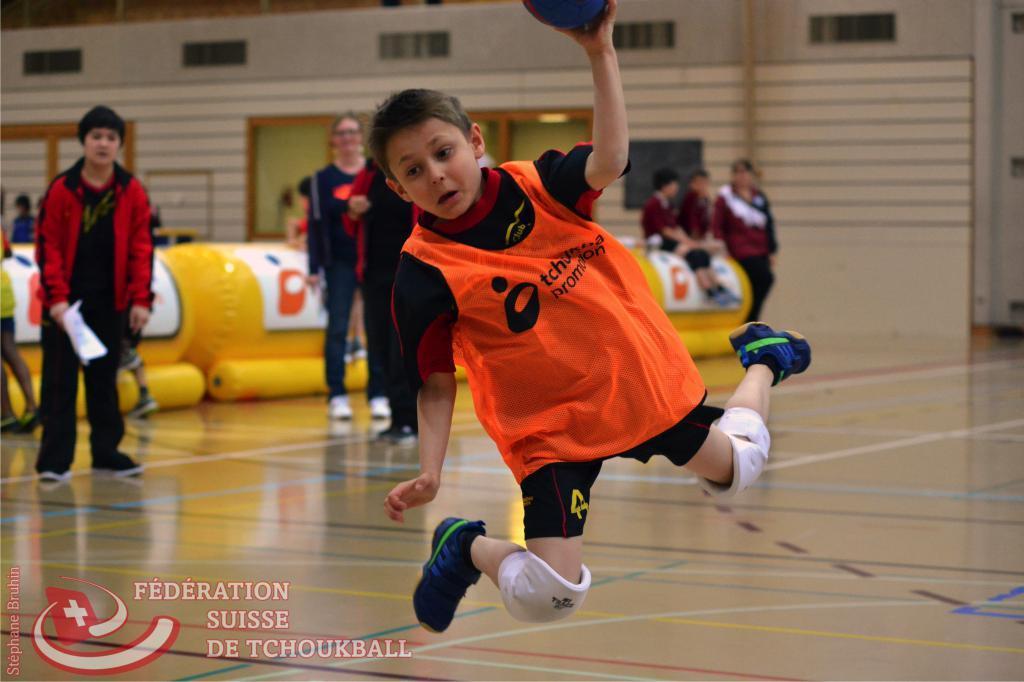Please provide a concise description of this image. In this image we can see a boy jumping into the air by holding a ball in his hand. In the background we can see wall, ventilators, windows and persons standing on the floor. 